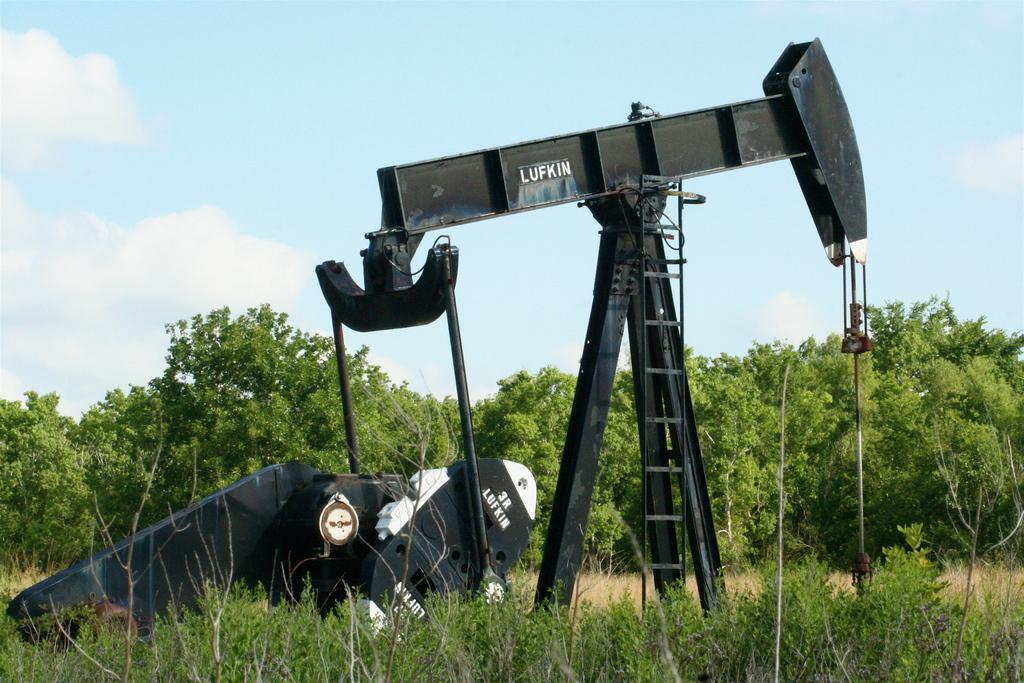What is the surface on which the objects are placed in the image? The objects are placed on the grass ground in the image. What type of vegetation can be seen in the image? There are many trees visible in the image. What is the rate at which the trees are growing in the image? The rate at which the trees are growing cannot be determined from the image. How many legs do the trees have in the image? Trees do not have legs, so this question is not applicable. 